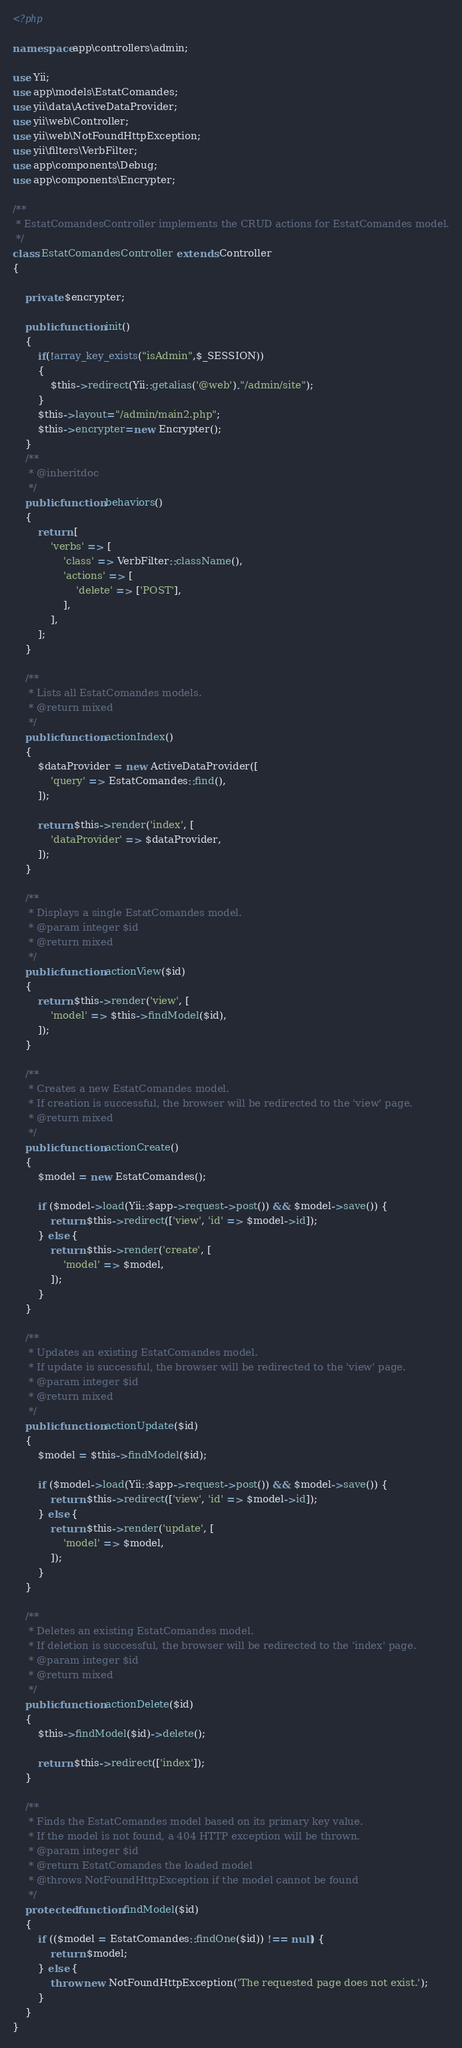Convert code to text. <code><loc_0><loc_0><loc_500><loc_500><_PHP_><?php

namespace app\controllers\admin;

use Yii;
use app\models\EstatComandes;
use yii\data\ActiveDataProvider;
use yii\web\Controller;
use yii\web\NotFoundHttpException;
use yii\filters\VerbFilter;
use app\components\Debug;
use app\components\Encrypter;

/**
 * EstatComandesController implements the CRUD actions for EstatComandes model.
 */
class EstatComandesController extends Controller
{

    private $encrypter;

    public function init()
    {
        if(!array_key_exists("isAdmin",$_SESSION))
        {
            $this->redirect(Yii::getalias('@web')."/admin/site");
        }
        $this->layout="/admin/main2.php";
        $this->encrypter=new Encrypter();
    }
    /**
     * @inheritdoc
     */
    public function behaviors()
    {
        return [
            'verbs' => [
                'class' => VerbFilter::className(),
                'actions' => [
                    'delete' => ['POST'],
                ],
            ],
        ];
    }

    /**
     * Lists all EstatComandes models.
     * @return mixed
     */
    public function actionIndex()
    {
        $dataProvider = new ActiveDataProvider([
            'query' => EstatComandes::find(),
        ]);

        return $this->render('index', [
            'dataProvider' => $dataProvider,
        ]);
    }

    /**
     * Displays a single EstatComandes model.
     * @param integer $id
     * @return mixed
     */
    public function actionView($id)
    {
        return $this->render('view', [
            'model' => $this->findModel($id),
        ]);
    }

    /**
     * Creates a new EstatComandes model.
     * If creation is successful, the browser will be redirected to the 'view' page.
     * @return mixed
     */
    public function actionCreate()
    {
        $model = new EstatComandes();

        if ($model->load(Yii::$app->request->post()) && $model->save()) {
            return $this->redirect(['view', 'id' => $model->id]);
        } else {
            return $this->render('create', [
                'model' => $model,
            ]);
        }
    }

    /**
     * Updates an existing EstatComandes model.
     * If update is successful, the browser will be redirected to the 'view' page.
     * @param integer $id
     * @return mixed
     */
    public function actionUpdate($id)
    {
        $model = $this->findModel($id);

        if ($model->load(Yii::$app->request->post()) && $model->save()) {
            return $this->redirect(['view', 'id' => $model->id]);
        } else {
            return $this->render('update', [
                'model' => $model,
            ]);
        }
    }

    /**
     * Deletes an existing EstatComandes model.
     * If deletion is successful, the browser will be redirected to the 'index' page.
     * @param integer $id
     * @return mixed
     */
    public function actionDelete($id)
    {
        $this->findModel($id)->delete();

        return $this->redirect(['index']);
    }

    /**
     * Finds the EstatComandes model based on its primary key value.
     * If the model is not found, a 404 HTTP exception will be thrown.
     * @param integer $id
     * @return EstatComandes the loaded model
     * @throws NotFoundHttpException if the model cannot be found
     */
    protected function findModel($id)
    {
        if (($model = EstatComandes::findOne($id)) !== null) {
            return $model;
        } else {
            throw new NotFoundHttpException('The requested page does not exist.');
        }
    }
}
</code> 